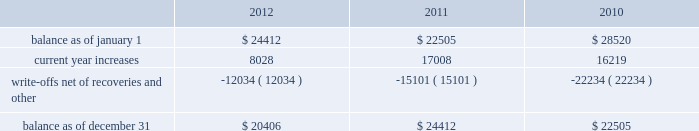American tower corporation and subsidiaries notes to consolidated financial statements when they are determined uncollectible .
Such determination includes analysis and consideration of the particular conditions of the account .
Changes in the allowances were as follows for the years ended december 31 , ( in thousands ) : .
Functional currency 2014as a result of changes to the organizational structure of the company 2019s subsidiaries in latin america in 2010 , the company determined that effective january 1 , 2010 , the functional currency of its foreign subsidiary in brazil is the brazilian real .
From that point forward , all assets and liabilities held by the subsidiary in brazil are translated into u.s .
Dollars at the exchange rate in effect at the end of the applicable reporting period .
Revenues and expenses are translated at the average monthly exchange rates and the cumulative translation effect is included in equity .
The change in functional currency from u.s .
Dollars to brazilian real gave rise to an increase in the net value of certain non-monetary assets and liabilities .
The aggregate impact on such assets and liabilities was $ 39.8 million with an offsetting increase in accumulated other comprehensive income during the year ended december 31 , 2010 .
As a result of the renegotiation of the company 2019s agreements with grupo iusacell , s.a .
De c.v .
( 201ciusacell 201d ) , which included , among other changes , converting iusacell 2019s contractual obligations to the company from u.s .
Dollars to mexican pesos , the company determined that effective april 1 , 2010 , the functional currency of certain of its foreign subsidiaries in mexico is the mexican peso .
From that point forward , all assets and liabilities held by those subsidiaries in mexico are translated into u.s .
Dollars at the exchange rate in effect at the end of the applicable reporting period .
Revenues and expenses are translated at the average monthly exchange rates and the cumulative translation effect is included in equity .
The change in functional currency from u.s .
Dollars to mexican pesos gave rise to a decrease in the net value of certain non-monetary assets and liabilities .
The aggregate impact on such assets and liabilities was $ 33.6 million with an offsetting decrease in accumulated other comprehensive income .
The functional currency of the company 2019s other foreign operating subsidiaries is also the respective local currency .
All assets and liabilities held by the subsidiaries are translated into u.s .
Dollars at the exchange rate in effect at the end of the applicable fiscal reporting period .
Revenues and expenses are translated at the average monthly exchange rates .
The cumulative translation effect is included in equity as a component of accumulated other comprehensive income .
Foreign currency transaction gains and losses are recognized in the consolidated statements of operations and are the result of transactions of a subsidiary being denominated in a currency other than its functional currency .
Cash and cash equivalents 2014cash and cash equivalents include cash on hand , demand deposits and short-term investments , including money market funds , with remaining maturities of three months or less when acquired , whose cost approximates fair value .
Restricted cash 2014the company classifies as restricted cash all cash pledged as collateral to secure obligations and all cash whose use is otherwise limited by contractual provisions , including cash on deposit in reserve accounts relating to the commercial mortgage pass-through certificates , series 2007-1 issued in the company 2019s securitization transaction and the secured cellular site revenue notes , series 2010-1 class c , series 2010-2 class c and series 2010-2 class f , assumed by the company as a result of the acquisition of certain legal entities from unison holdings , llc and unison site management ii , l.l.c .
( collectively , 201cunison 201d ) . .
For 2012 , what was the current allowance as a percent of the beginning balance? 
Computations: (8028 / 24412)
Answer: 0.32885. 